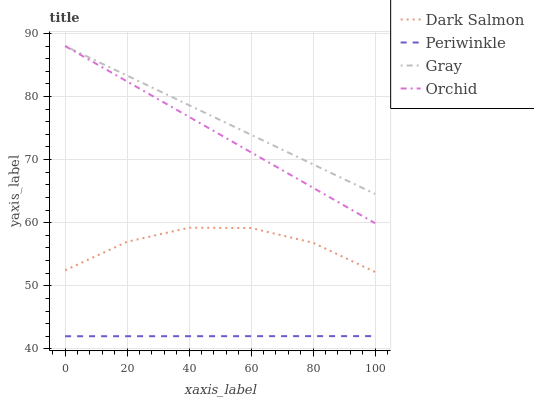Does Periwinkle have the minimum area under the curve?
Answer yes or no. Yes. Does Gray have the maximum area under the curve?
Answer yes or no. Yes. Does Dark Salmon have the minimum area under the curve?
Answer yes or no. No. Does Dark Salmon have the maximum area under the curve?
Answer yes or no. No. Is Orchid the smoothest?
Answer yes or no. Yes. Is Dark Salmon the roughest?
Answer yes or no. Yes. Is Periwinkle the smoothest?
Answer yes or no. No. Is Periwinkle the roughest?
Answer yes or no. No. Does Periwinkle have the lowest value?
Answer yes or no. Yes. Does Dark Salmon have the lowest value?
Answer yes or no. No. Does Orchid have the highest value?
Answer yes or no. Yes. Does Dark Salmon have the highest value?
Answer yes or no. No. Is Periwinkle less than Gray?
Answer yes or no. Yes. Is Gray greater than Dark Salmon?
Answer yes or no. Yes. Does Gray intersect Orchid?
Answer yes or no. Yes. Is Gray less than Orchid?
Answer yes or no. No. Is Gray greater than Orchid?
Answer yes or no. No. Does Periwinkle intersect Gray?
Answer yes or no. No. 